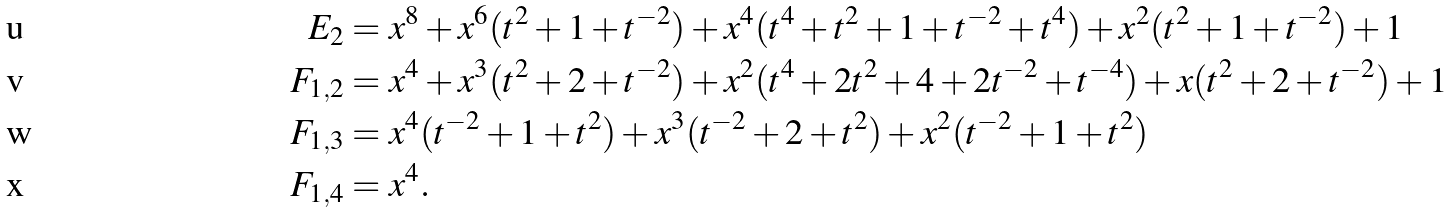<formula> <loc_0><loc_0><loc_500><loc_500>E _ { 2 } & = x ^ { 8 } + x ^ { 6 } ( t ^ { 2 } + 1 + t ^ { - 2 } ) + x ^ { 4 } ( t ^ { 4 } + t ^ { 2 } + 1 + t ^ { - 2 } + t ^ { 4 } ) + x ^ { 2 } ( t ^ { 2 } + 1 + t ^ { - 2 } ) + 1 \\ F _ { 1 , 2 } & = x ^ { 4 } + x ^ { 3 } ( t ^ { 2 } + 2 + t ^ { - 2 } ) + x ^ { 2 } ( t ^ { 4 } + 2 t ^ { 2 } + 4 + 2 t ^ { - 2 } + t ^ { - 4 } ) + x ( t ^ { 2 } + 2 + t ^ { - 2 } ) + 1 \\ F _ { 1 , 3 } & = x ^ { 4 } ( t ^ { - 2 } + 1 + t ^ { 2 } ) + x ^ { 3 } ( t ^ { - 2 } + 2 + t ^ { 2 } ) + x ^ { 2 } ( t ^ { - 2 } + 1 + t ^ { 2 } ) \\ F _ { 1 , 4 } & = x ^ { 4 } .</formula> 